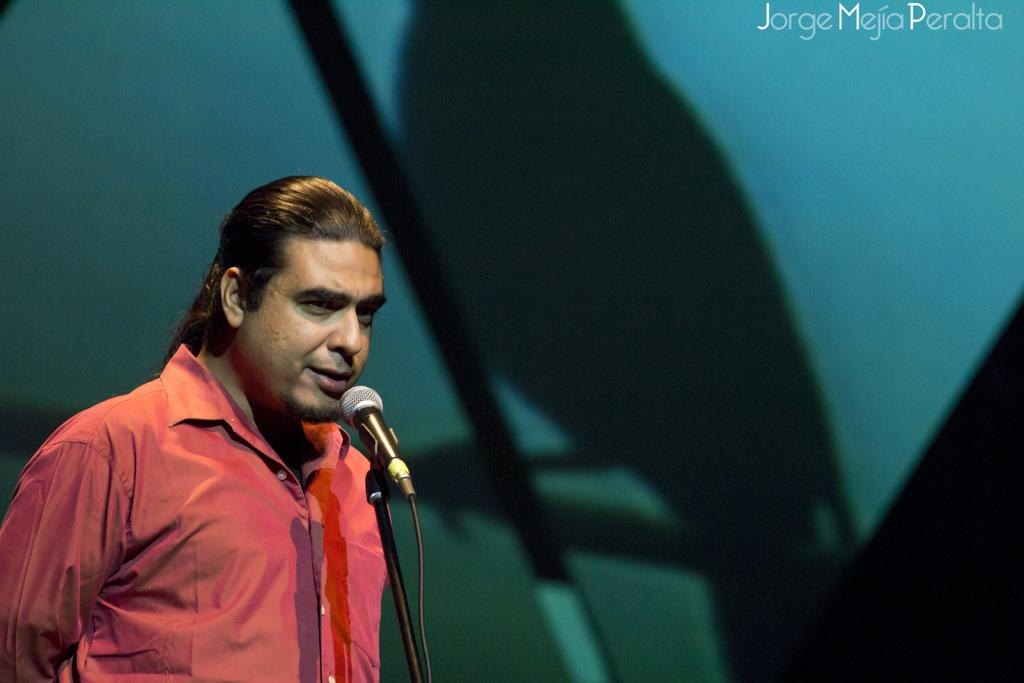What is the man in the image doing? The man is standing in front of a microphone and speaking. Where is the microphone located in the image? The microphone is in the center of the image. Can you describe anything in the background of the image? There is a shadow of a bird in the background of the image. What type of knife is the man using to cut his birthday cake in the image? There is no knife or birthday cake present in the image; the man is speaking into a microphone. 